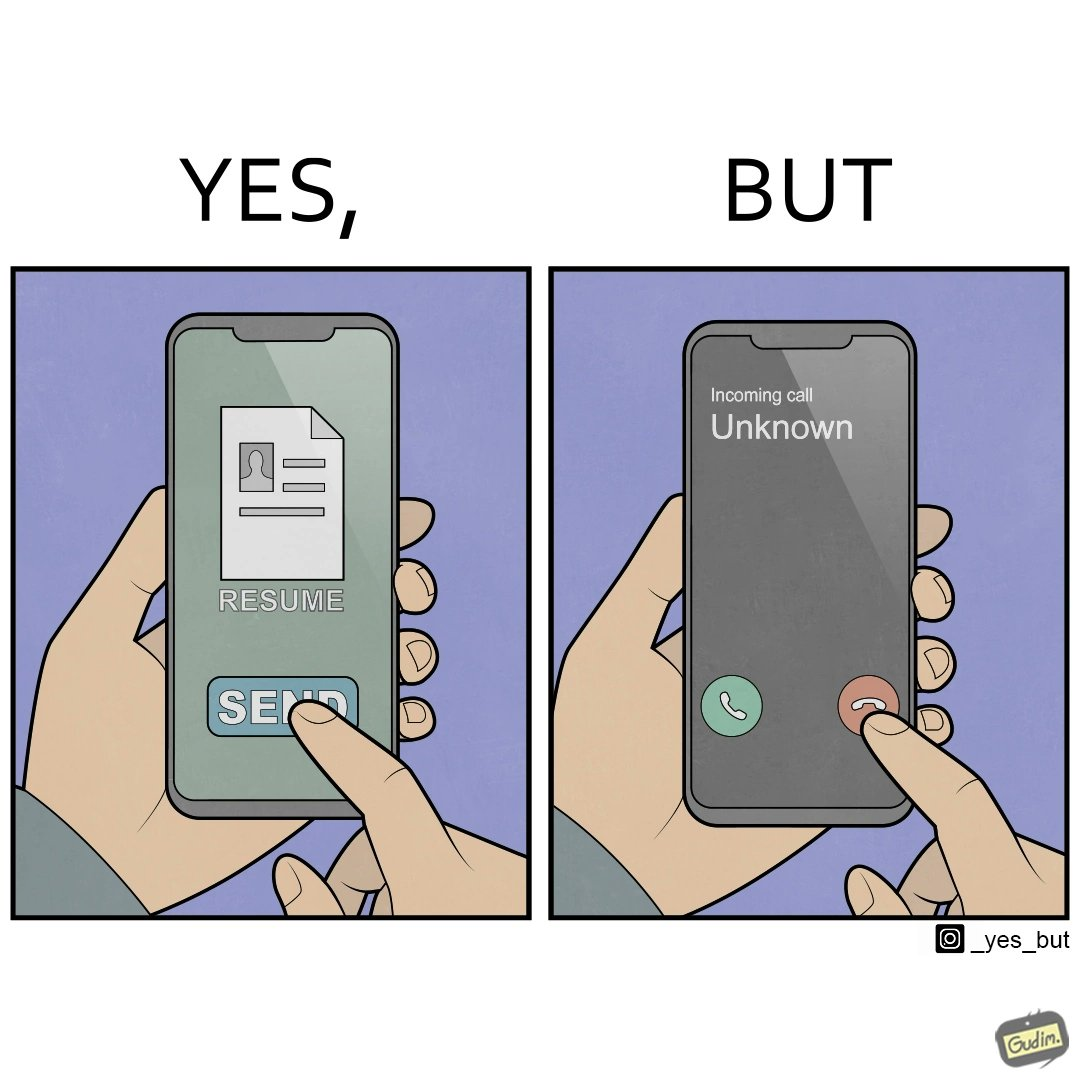Explain the humor or irony in this image. The image is ironic, because on the left image the person is sending their resume to someone and on the right they are rejecting the unknown calls which might be some offer calls  or the person who sent the resume maybe tired of the spam calls after sending the resume which he sent seeking some new oppurtunities 